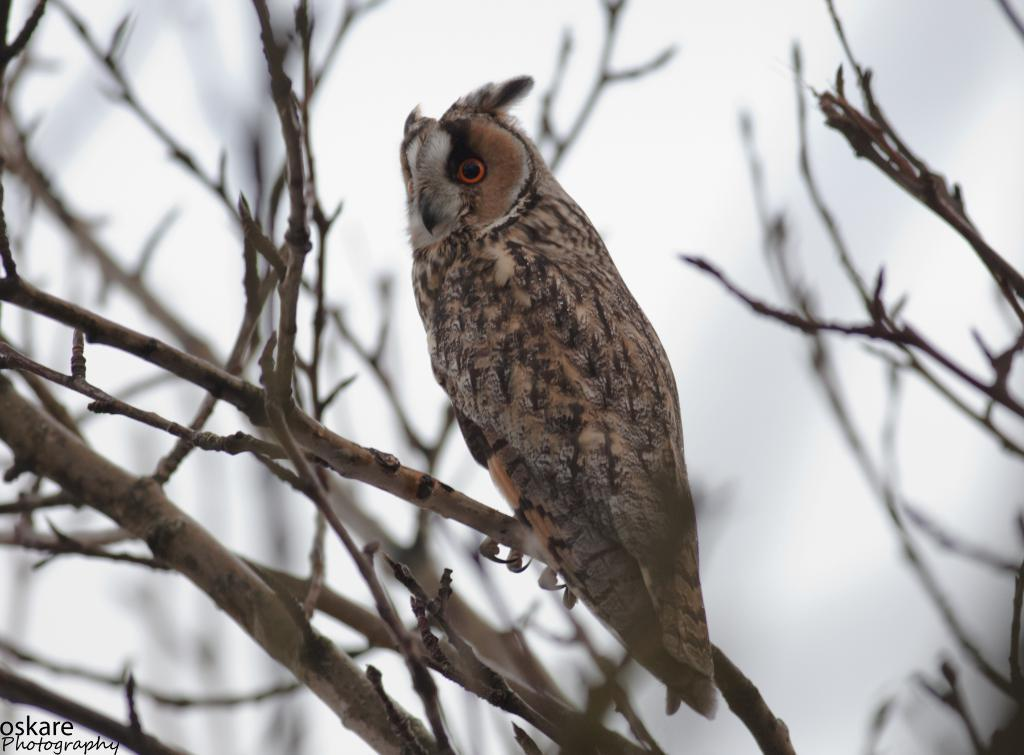What type of animal is present in the image? There is a bird in the image. Where is the bird located in the image? The bird is on a branch. What type of fruit is the bird eating in the image? There is no fruit present in the image, and therefore no such activity can be observed. 